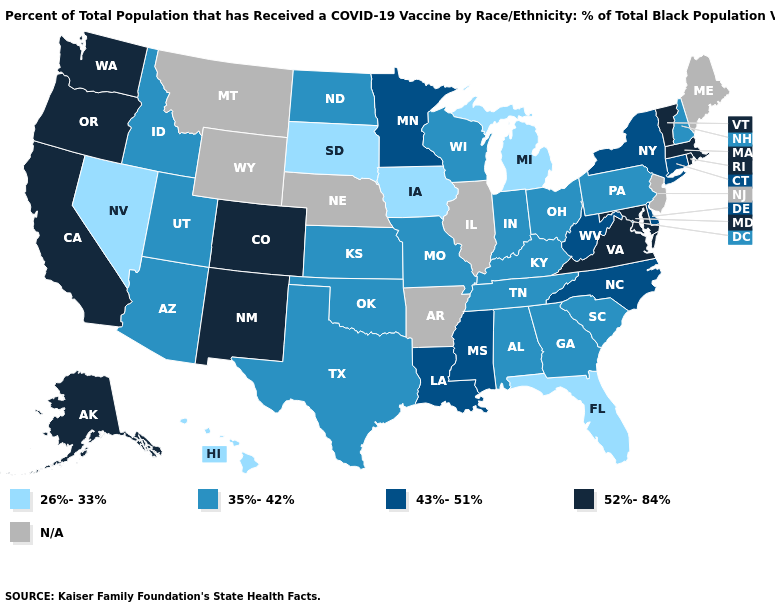Name the states that have a value in the range 43%-51%?
Keep it brief. Connecticut, Delaware, Louisiana, Minnesota, Mississippi, New York, North Carolina, West Virginia. What is the lowest value in states that border South Dakota?
Keep it brief. 26%-33%. What is the value of Alabama?
Quick response, please. 35%-42%. Does Washington have the highest value in the USA?
Keep it brief. Yes. Among the states that border California , does Nevada have the lowest value?
Write a very short answer. Yes. Name the states that have a value in the range 43%-51%?
Write a very short answer. Connecticut, Delaware, Louisiana, Minnesota, Mississippi, New York, North Carolina, West Virginia. What is the lowest value in the Northeast?
Quick response, please. 35%-42%. Among the states that border Rhode Island , which have the lowest value?
Concise answer only. Connecticut. Which states have the lowest value in the USA?
Quick response, please. Florida, Hawaii, Iowa, Michigan, Nevada, South Dakota. What is the value of Nebraska?
Concise answer only. N/A. Does Washington have the lowest value in the USA?
Short answer required. No. What is the highest value in the USA?
Be succinct. 52%-84%. 